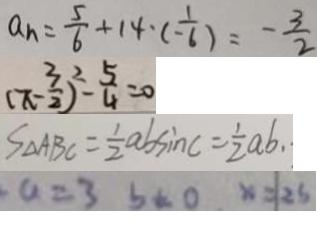<formula> <loc_0><loc_0><loc_500><loc_500>a _ { n } = \frac { 5 } { 6 } + 1 4 \cdot ( - \frac { 1 } { 6 } ) = - \frac { 3 } { 2 } 
 ( \pi - \frac { 3 } { 2 } ) ^ { 2 } - \frac { 5 } { 4 } = 0 
 S _ { \Delta } A B C = \frac { 1 } { 2 } a b \sin c = \frac { 1 } { 2 } a b . . 
 a = 3 b = 0 x = 2 5</formula> 